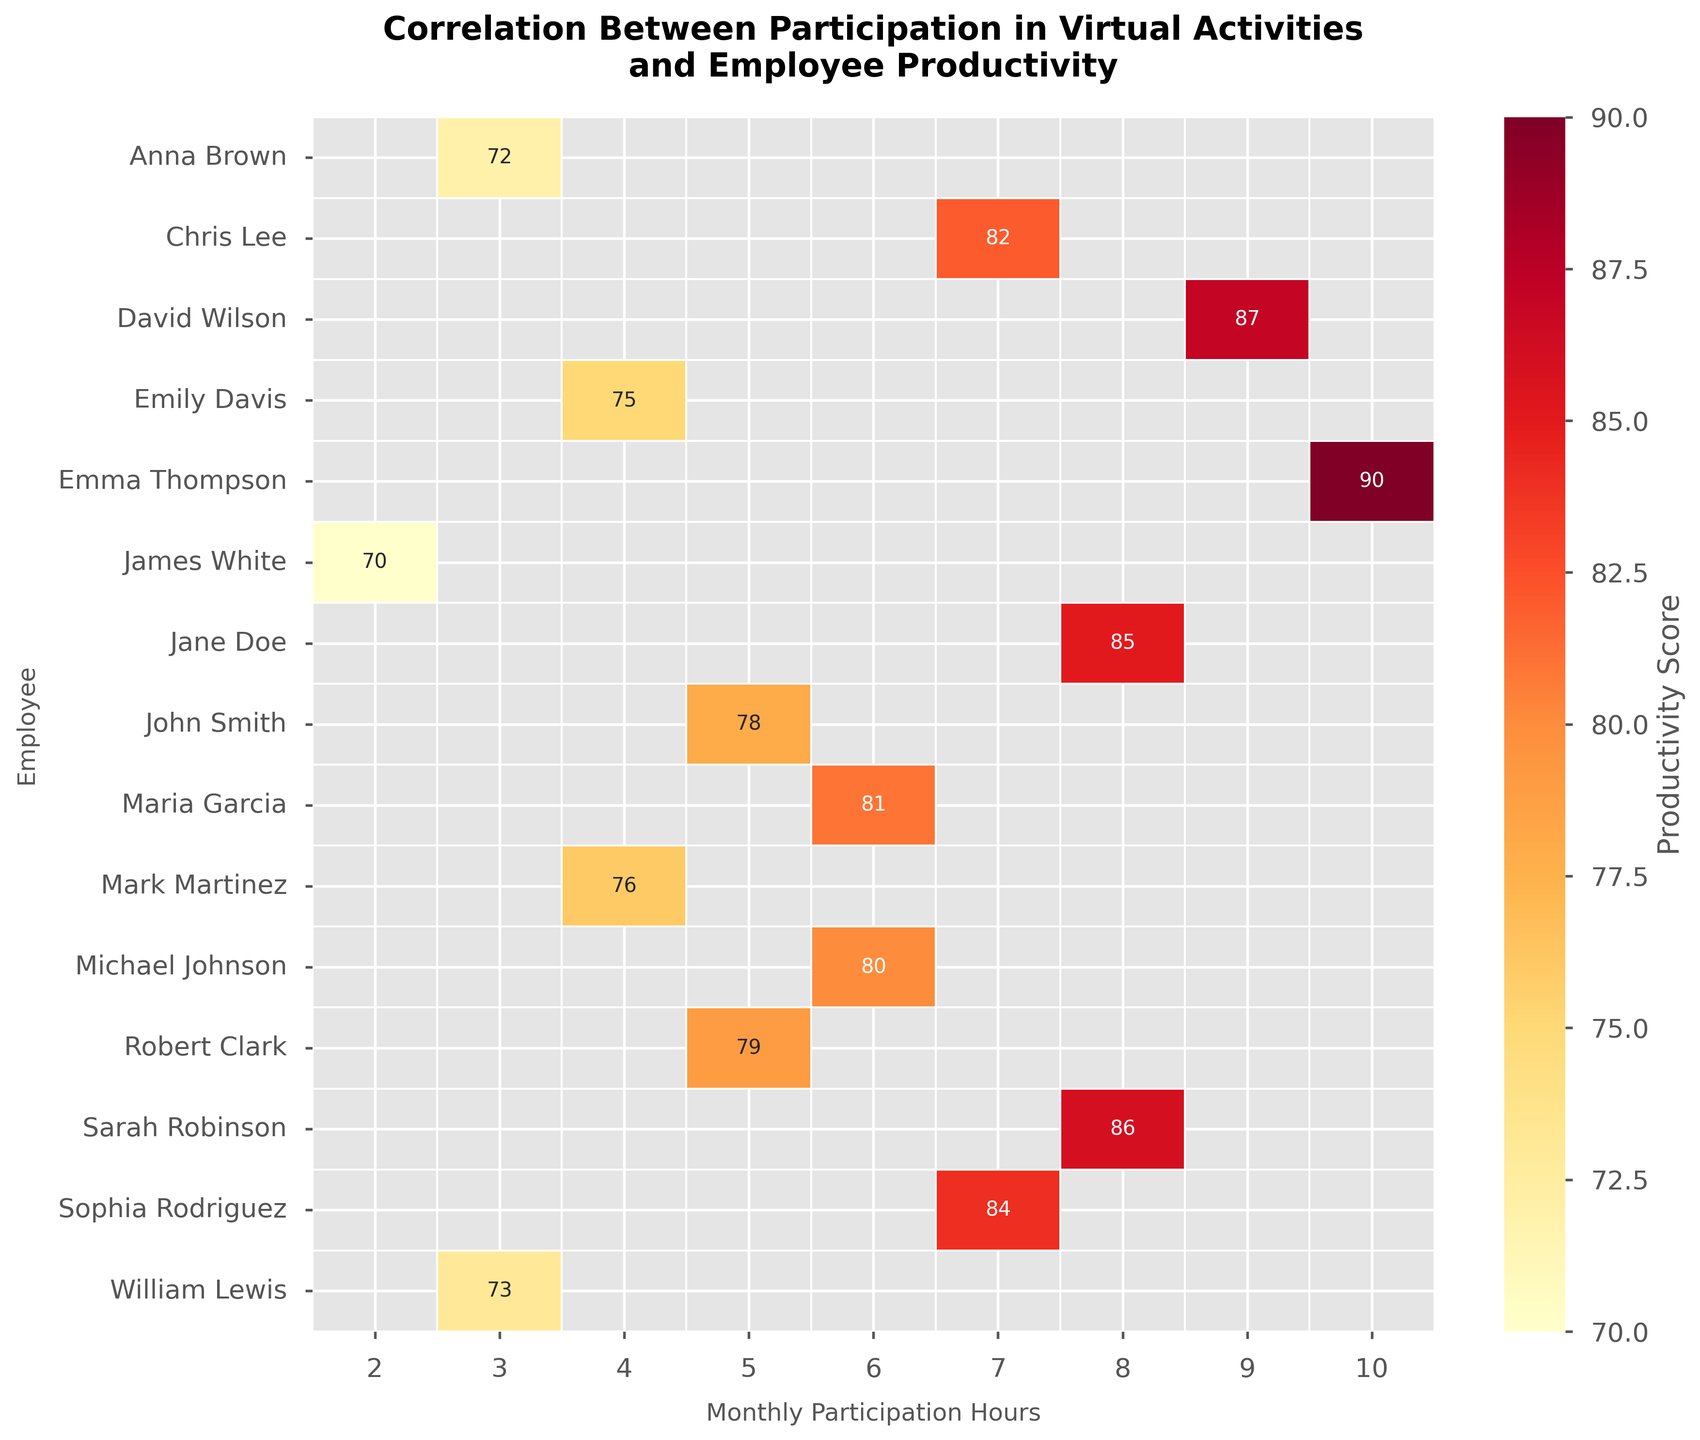What's the title of the heatmap? The title of the heatmap is displayed at the top of the chart.
Answer: Correlation Between Participation in Virtual Activities and Employee Productivity What does the x-axis represent? The x-axis represents "Monthly Participation Hours" which indicates how many hours each employee participated in virtual activities per month.
Answer: Monthly Participation Hours Identify the employee with the highest participation hours. Look at the x-axis and find the highest value. Then, see which employee corresponds to that value.
Answer: Emma Thompson Which employee has a productivity score of 85? Look at the cells in the heatmap to find the cell with the value '85'. Then, identify the corresponding employee from the y-axis.
Answer: Jane Doe What is the range of the productivity scores shown in the heatmap? Identify the minimum and maximum productivity score values visible in the heatmap.
Answer: 70 to 90 How many employees participated in virtual activities for 4 hours monthly? Count the number of employees/rows where the x-axis value (Monthly Participation Hours) corresponds to 4.
Answer: 2 Compare the productivity scores of employees who participated for 6 hours and 9 hours. Find all cells for 6 hours and 9 hours in the heatmap and compare their values. For 6 hours: Michael Johnson (80), Maria Garcia (81). For 9 hours: David Wilson (87).
Answer: 80, 81 vs. 87 Who has a higher productivity score, John Smith or Robert Clark? Compare the productivity scores of the two employees by finding their respective cells in the heatmap. John Smith has 78 and Robert Clark has 79.
Answer: Robert Clark What is the average productivity score of employees who spent more than 7 hours in virtual activities? First, identify the employees who spent more than 7 hours, which are Jane Doe (85), David Wilson (87), Emma Thompson (90), Sarah Robinson (86). Then calculate their average score: (85 + 87 + 90 + 86) / 4 = 87.
Answer: 87 Does any employee who participated for fewer than 5 hours have a productivity score above 75? Check all cells where the participation hours are fewer than 5 (John Smith, Emily Davis, Anna Brown, James White, Mark Martinez, William Lewis) and see if any have a productivity score above 75. John Smith (78), Emily Davis (75), Anna Brown (72), James White (70), Mark Martinez (76), William Lewis (73).
Answer: Yes 